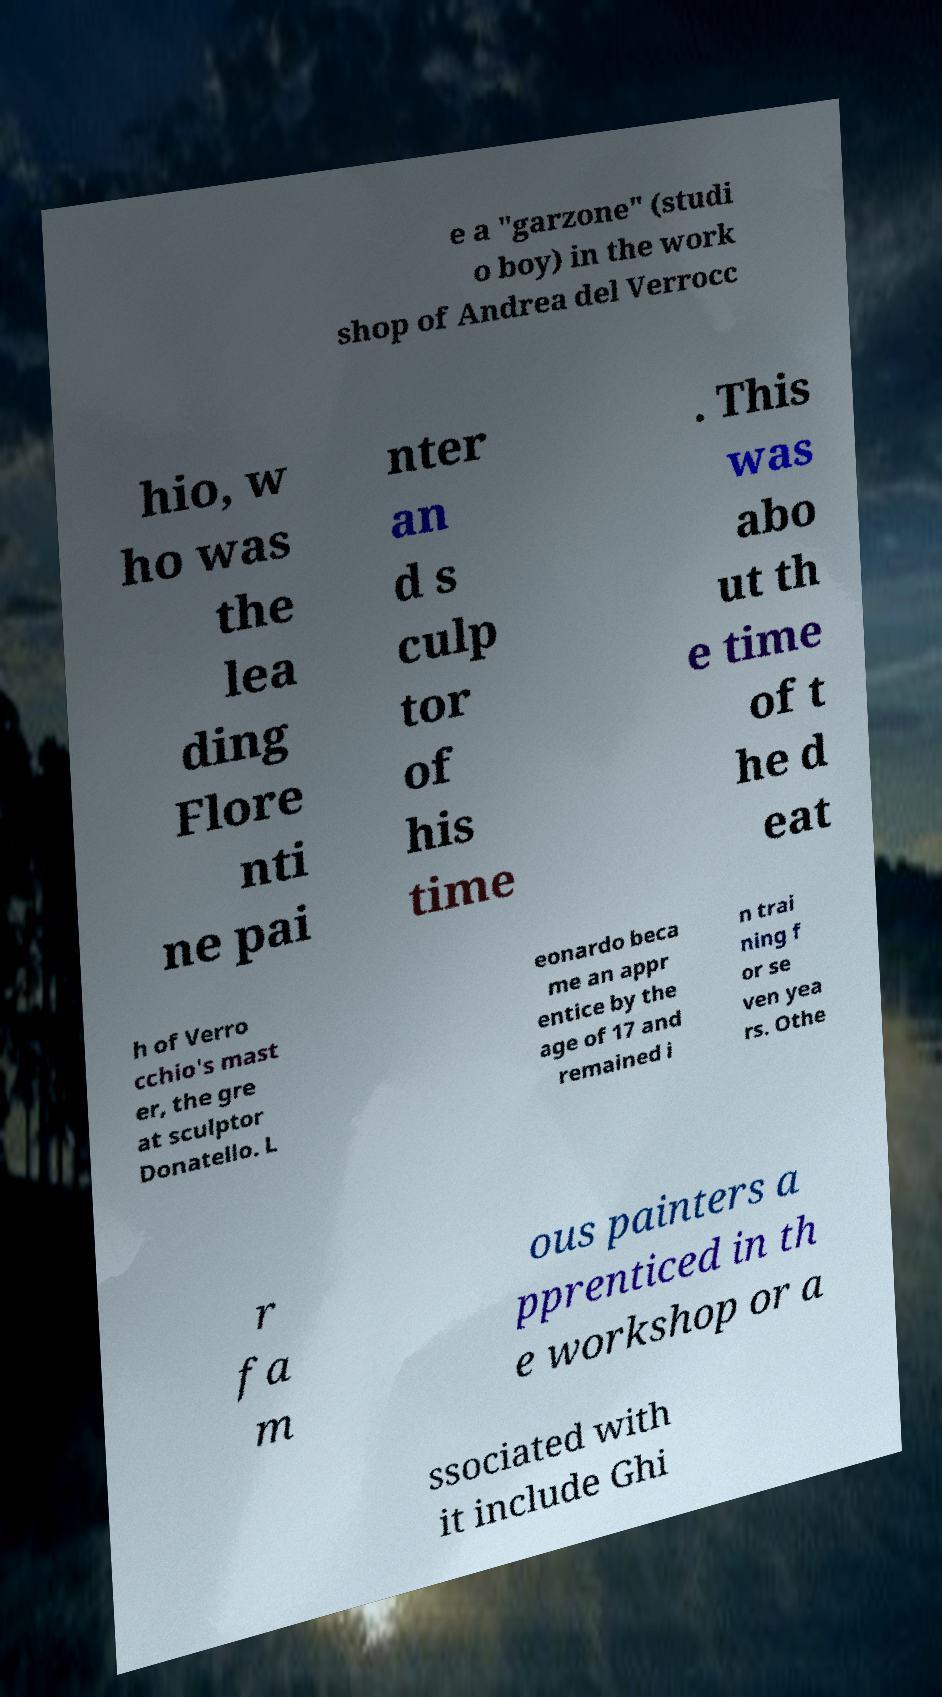Could you extract and type out the text from this image? e a "garzone" (studi o boy) in the work shop of Andrea del Verrocc hio, w ho was the lea ding Flore nti ne pai nter an d s culp tor of his time . This was abo ut th e time of t he d eat h of Verro cchio's mast er, the gre at sculptor Donatello. L eonardo beca me an appr entice by the age of 17 and remained i n trai ning f or se ven yea rs. Othe r fa m ous painters a pprenticed in th e workshop or a ssociated with it include Ghi 